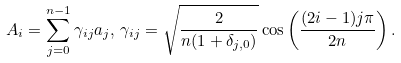<formula> <loc_0><loc_0><loc_500><loc_500>A _ { i } = \sum _ { j = 0 } ^ { n - 1 } \gamma _ { i j } a _ { j } , \, \gamma _ { i j } = \sqrt { \frac { 2 } { n ( 1 + \delta _ { j , 0 } ) } } \cos \left ( \frac { ( 2 i - 1 ) j \pi } { 2 n } \right ) .</formula> 